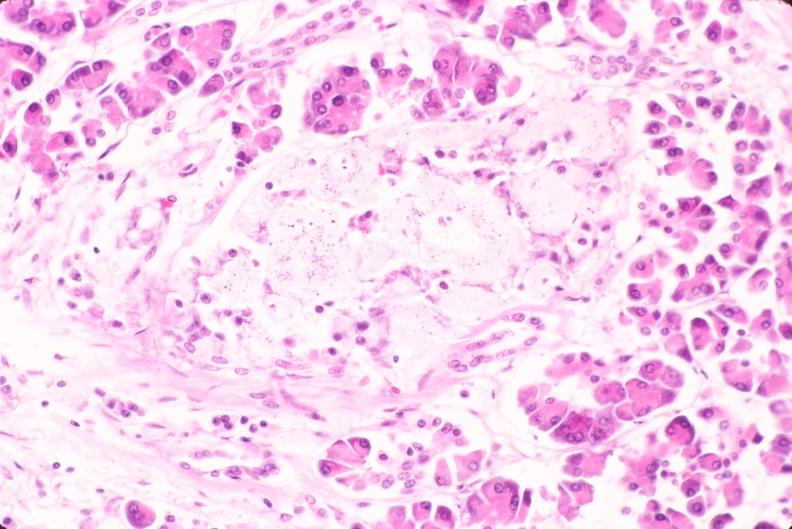does this image show pancreas, islet hyalinization, diabetes mellitus?
Answer the question using a single word or phrase. Yes 